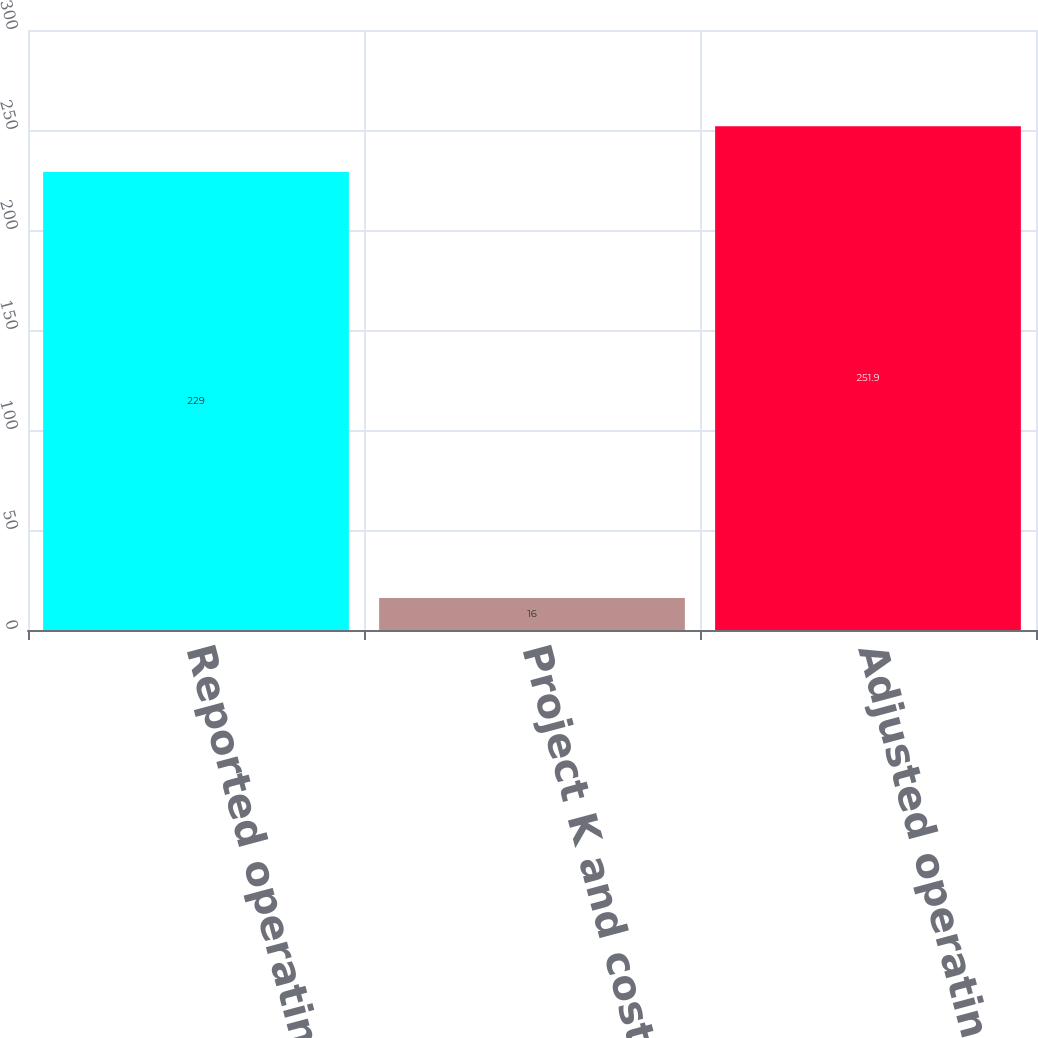<chart> <loc_0><loc_0><loc_500><loc_500><bar_chart><fcel>Reported operating profit<fcel>Project K and cost reduction<fcel>Adjusted operating profit<nl><fcel>229<fcel>16<fcel>251.9<nl></chart> 